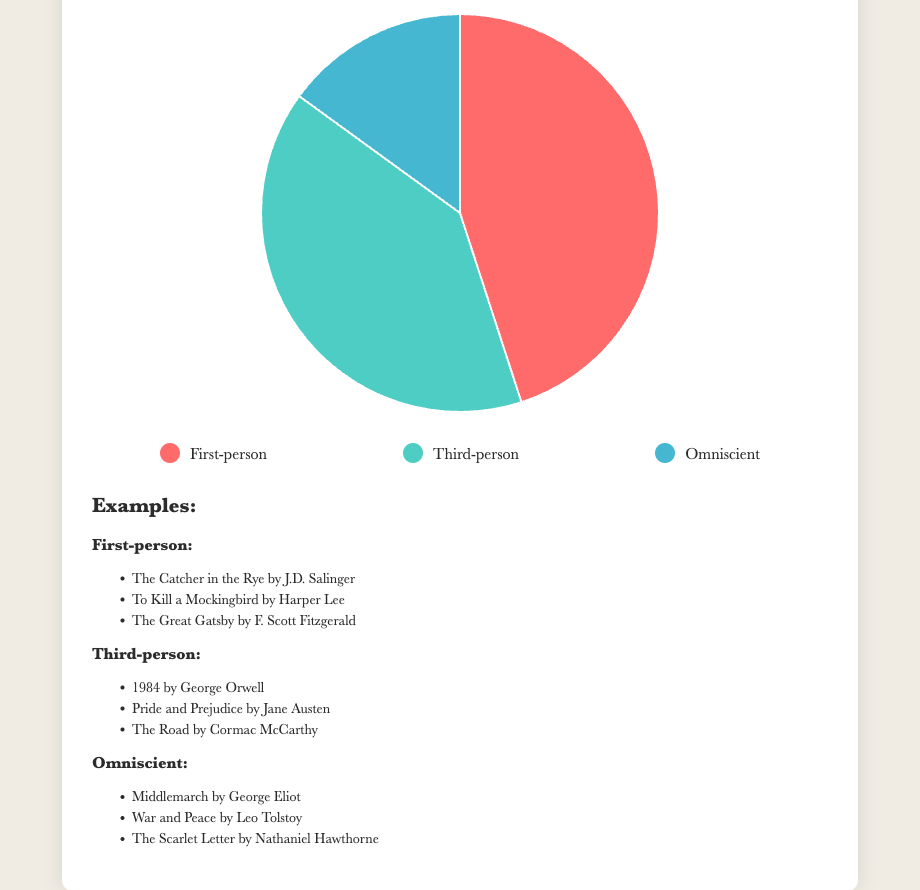Which narrative perspective has the highest distribution? The figure shows that First-person has the highest percentage at 45%.
Answer: First-person What is the difference in percentage between First-person and Third-person perspectives? The figure shows that First-person is 45% and Third-person is 40%. The difference is 45% - 40% = 5%.
Answer: 5% What percentage of novels use either Third-person or Omniscient perspectives? Add the percentages of Third-person and Omniscient: 40% + 15% = 55%.
Answer: 55% Which narrative perspective has the smallest distribution? The figure shows that Omniscient has the smallest percentage at 15%.
Answer: Omniscient How much greater is the percentage of First-person novels compared to Omniscient novels? The figure shows that the First-person percentage is 45% and Omniscient is 15%. The difference is 45% - 15% = 30%.
Answer: 30% What is the total percentage of novels represented in the chart? The total of all provided percentages is 45% + 40% + 15% = 100%.
Answer: 100% Which section of the pie chart is colored red? The legend indicates that red corresponds to First-person, which has a 45% distribution.
Answer: First-person Which narrative perspectives are almost equally distributed? The figure shows that First-person is 45% and Third-person is 40%, which are close in value.
Answer: First-person, Third-person Describe the distribution of Omniscient perspective novels in terms of visual representation. The pie chart shows that Omniscient takes up a smaller segment compared to First-person and Third-person, visually representing its 15% distribution.
Answer: Smaller segment at 15% 